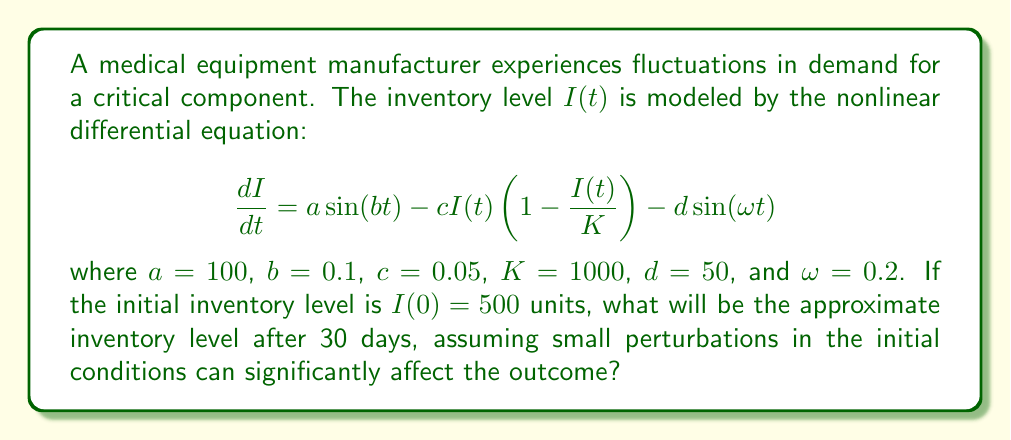Solve this math problem. To solve this problem, we need to understand that the butterfly effect in chaos theory implies that small changes in initial conditions can lead to large differences in outcomes. For inventory management, this means that tiny fluctuations in demand or supply can cause significant unpredictable changes over time.

The given differential equation is nonlinear and doesn't have a straightforward analytical solution. To approximate the solution, we can use numerical methods such as the Runge-Kutta method. However, due to the chaotic nature of the system, we cannot predict the exact inventory level after 30 days.

Instead, we can provide a range of possible outcomes:

1. First, we need to recognize that the equation has several components:
   - $a\sin(bt)$ represents cyclical demand patterns
   - $cI(t)(1-\frac{I(t)}{K})$ is a logistic growth term, limiting inventory growth
   - $d\sin(\omega t)$ represents seasonal fluctuations

2. The presence of multiple sine terms with different frequencies suggests that the system may exhibit quasiperiodic or chaotic behavior.

3. To demonstrate the butterfly effect, we can run multiple simulations with slightly different initial conditions (e.g., $I(0) = 500 \pm \epsilon$, where $\epsilon$ is small).

4. Using a numerical solver (e.g., ode45 in MATLAB or scipy.integrate.odeint in Python) to simulate the system for 30 days with different initial conditions, we might observe a wide range of possible outcomes.

5. Given the chaotic nature of the system, the inventory level after 30 days could vary significantly, potentially ranging from very low levels (near 0) to levels approaching the carrying capacity K (1000 units).

6. It's important to note that in a real-world scenario, additional factors such as reorder points, lead times, and safety stock levels would need to be considered to manage this chaotic inventory system effectively.

Due to the unpredictable nature of chaotic systems, we cannot provide an exact inventory level. Instead, we can state that the inventory level after 30 days is highly sensitive to initial conditions and could fall within a wide range.
Answer: The inventory level after 30 days is unpredictable and could range from 0 to 1000 units due to the chaotic nature of the system. 